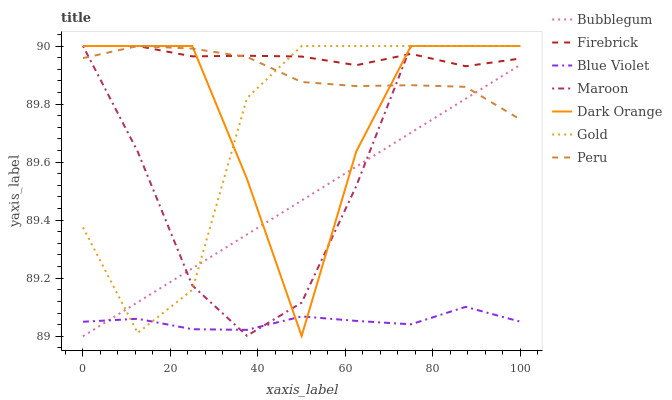Does Gold have the minimum area under the curve?
Answer yes or no. No. Does Gold have the maximum area under the curve?
Answer yes or no. No. Is Gold the smoothest?
Answer yes or no. No. Is Gold the roughest?
Answer yes or no. No. Does Gold have the lowest value?
Answer yes or no. No. Does Bubblegum have the highest value?
Answer yes or no. No. Is Blue Violet less than Peru?
Answer yes or no. Yes. Is Firebrick greater than Bubblegum?
Answer yes or no. Yes. Does Blue Violet intersect Peru?
Answer yes or no. No. 